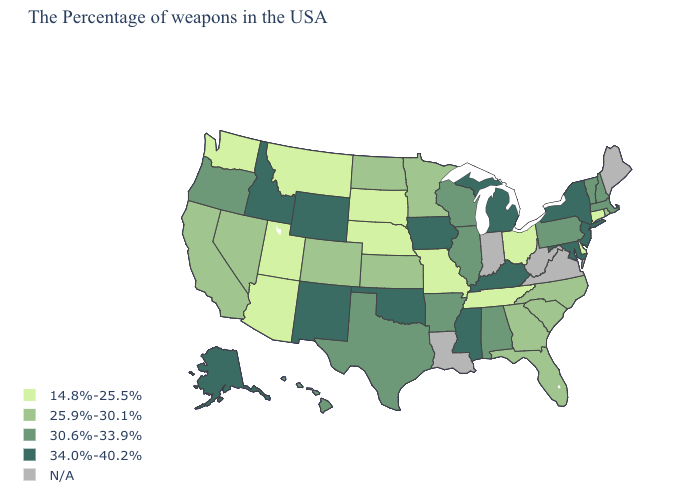Does Texas have the highest value in the South?
Write a very short answer. No. Which states have the lowest value in the MidWest?
Be succinct. Ohio, Missouri, Nebraska, South Dakota. What is the value of Virginia?
Keep it brief. N/A. Name the states that have a value in the range 30.6%-33.9%?
Quick response, please. Massachusetts, New Hampshire, Vermont, Pennsylvania, Alabama, Wisconsin, Illinois, Arkansas, Texas, Oregon, Hawaii. What is the value of Illinois?
Be succinct. 30.6%-33.9%. Name the states that have a value in the range 30.6%-33.9%?
Keep it brief. Massachusetts, New Hampshire, Vermont, Pennsylvania, Alabama, Wisconsin, Illinois, Arkansas, Texas, Oregon, Hawaii. Among the states that border Washington , does Oregon have the highest value?
Quick response, please. No. Does Rhode Island have the lowest value in the Northeast?
Write a very short answer. No. What is the lowest value in the USA?
Answer briefly. 14.8%-25.5%. What is the lowest value in states that border Idaho?
Concise answer only. 14.8%-25.5%. Among the states that border Missouri , does Illinois have the lowest value?
Keep it brief. No. Which states hav the highest value in the Northeast?
Concise answer only. New York, New Jersey. What is the value of Utah?
Concise answer only. 14.8%-25.5%. Which states have the highest value in the USA?
Answer briefly. New York, New Jersey, Maryland, Michigan, Kentucky, Mississippi, Iowa, Oklahoma, Wyoming, New Mexico, Idaho, Alaska. 